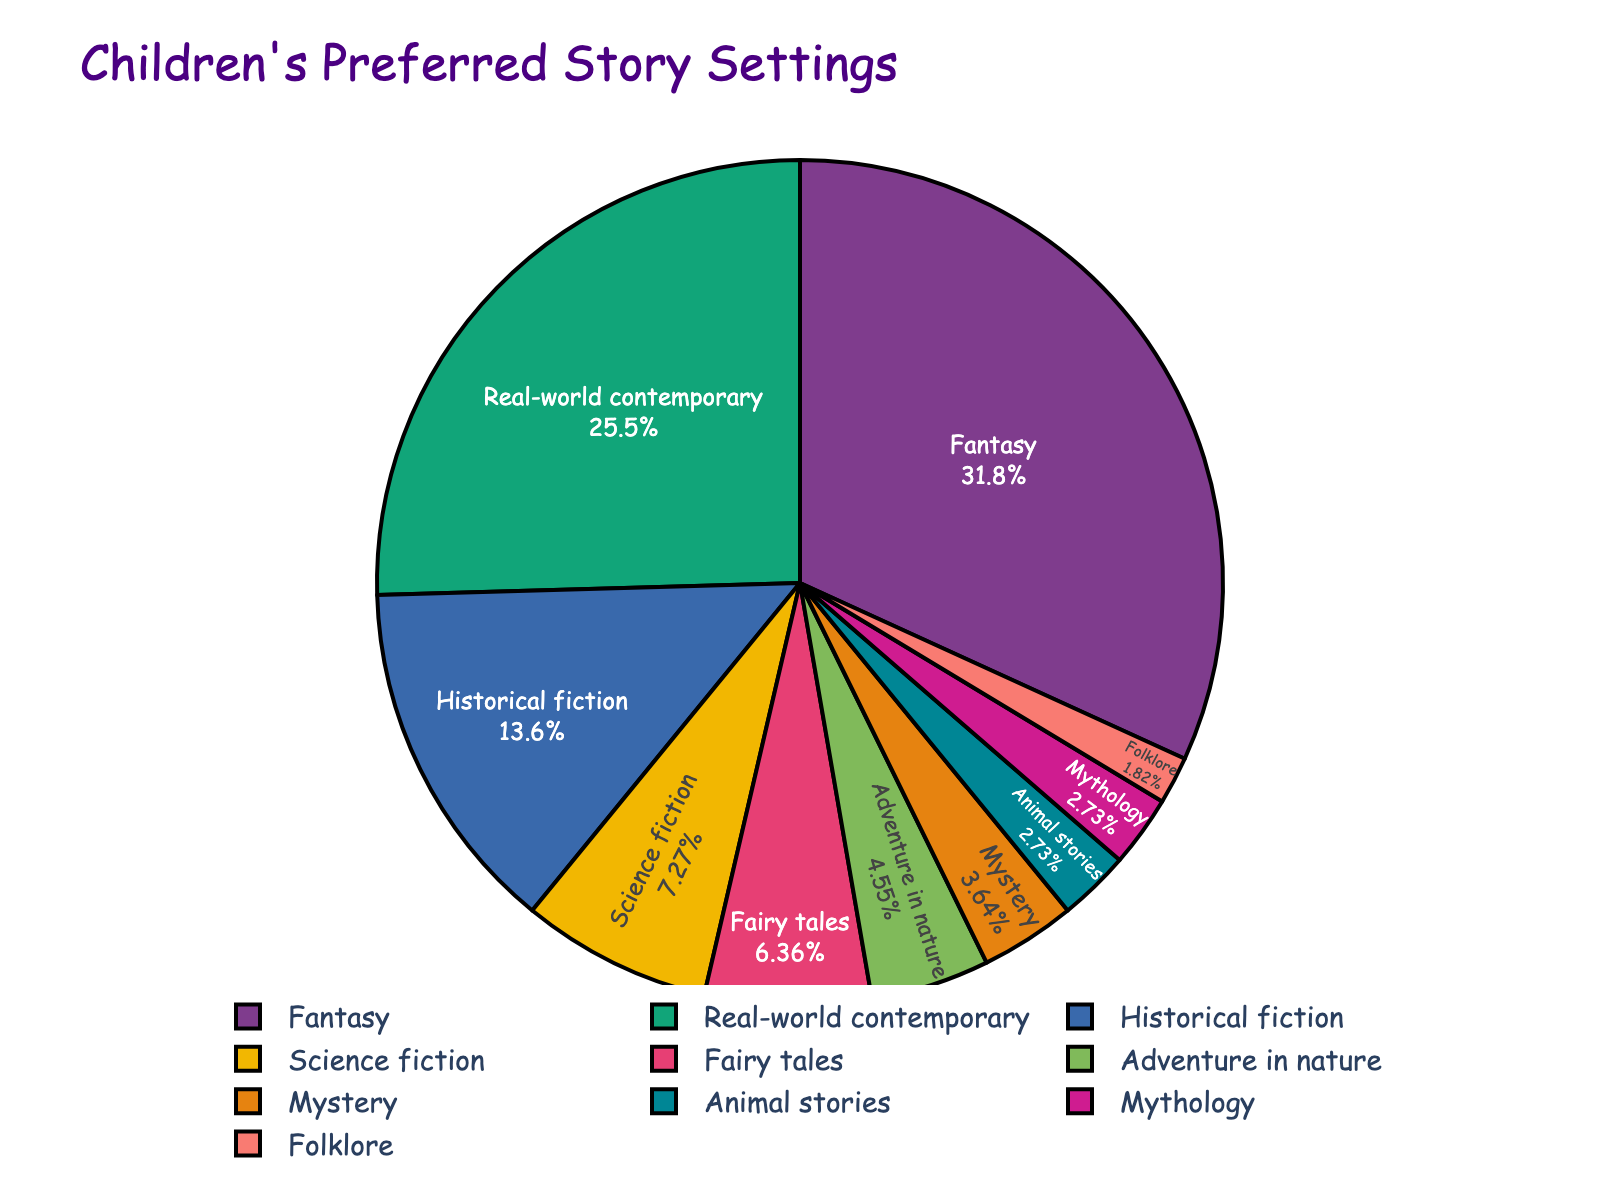Which story setting is the most preferred among children? The biggest slice of the pie chart represents the setting with the highest percentage. In this case, the "Fantasy" setting is the largest, indicating it is the most preferred.
Answer: Fantasy Which settings are preferred by more than 10% of children? Look at the slices that represent more than 10% of the pie chart. They are "Fantasy" (35%), "Real-world contemporary" (28%), and "Historical fiction" (15%).
Answer: Fantasy, Real-world contemporary, Historical fiction How does the preference for science fiction compare to the preference for historical fiction? Identify the slices for "Science fiction" (8%) and "Historical fiction" (15%) and compare their sizes. Historical fiction is preferred more than science fiction.
Answer: Historical fiction is preferred more than science fiction What percentage of children prefer settings that are neither fantasy nor real-world contemporary? Sum the percentages of all settings except "Fantasy" (35%) and "Real-world contemporary" (28%): 100% - 35% - 28% = 37%.
Answer: 37% By what factor is the preference for adventure in nature greater than the preference for animal stories? Find the percentages for "Adventure in nature" (5%) and "Animal stories" (3%) and then divide 5% by 3% to get the factor. Factor = 5 / 3 ≈ 1.67.
Answer: Approximately 1.67 What are the two least preferred story settings, and what are their combined percentages? Look for the two smallest slices in the pie chart, "Folklore" (2%) and "Mythology" (3%), and add their percentages: 2% + 3% = 5%.
Answer: Folklore and Mythology, 5% Which setting is preferred by twice as many children as the preference for mystery stories? Identify that "Mystery" is 4% and then find the setting with roughly 8%. "Science fiction" has 8%, which is twice the preference for "Mystery".
Answer: Science fiction What is the total percentage of children who prefer either fairy tales, adventure in nature, or mystery settings? Add the percentages for "Fairy tales" (7%), "Adventure in nature" (5%), and "Mystery" (4%): 7% + 5% + 4% = 16%.
Answer: 16% How much more popular are fantasy settings compared to fairy tales? Subtract the percentage of "Fairy tales" (7%) from "Fantasy" (35%): 35% - 7% = 28%.
Answer: 28% more What is the total percentage of children who prefer any setting that includes historical elements (historical fiction and mythology)? Add the percentages for "Historical fiction" (15%) and "Mythology" (3%): 15% + 3% = 18%.
Answer: 18% 